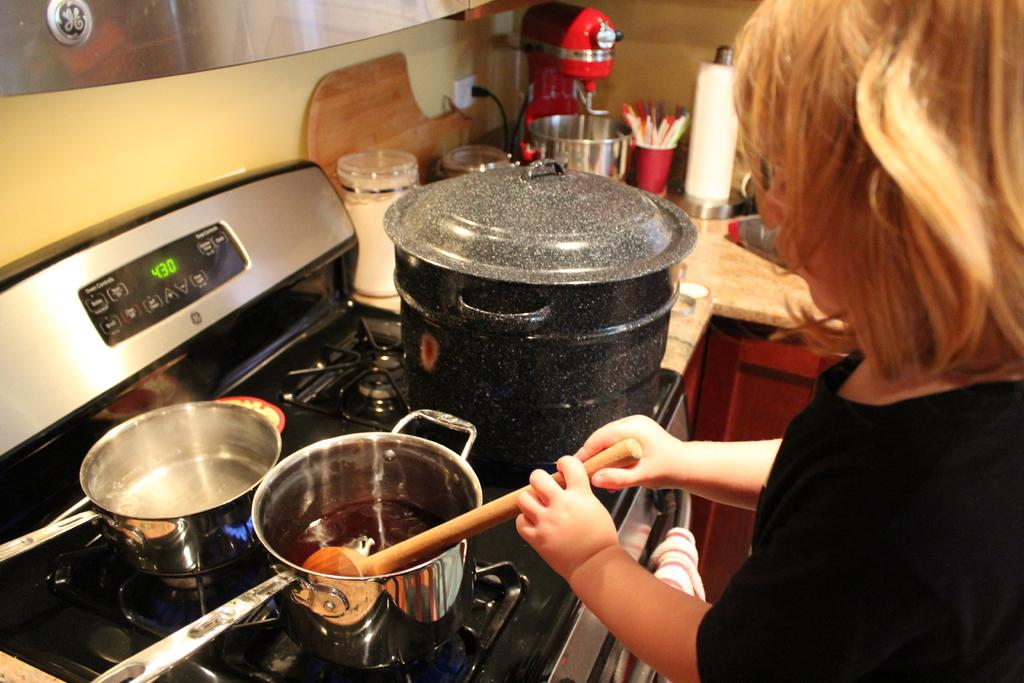What is the time shown on the stove?
Provide a succinct answer. 4:30. 